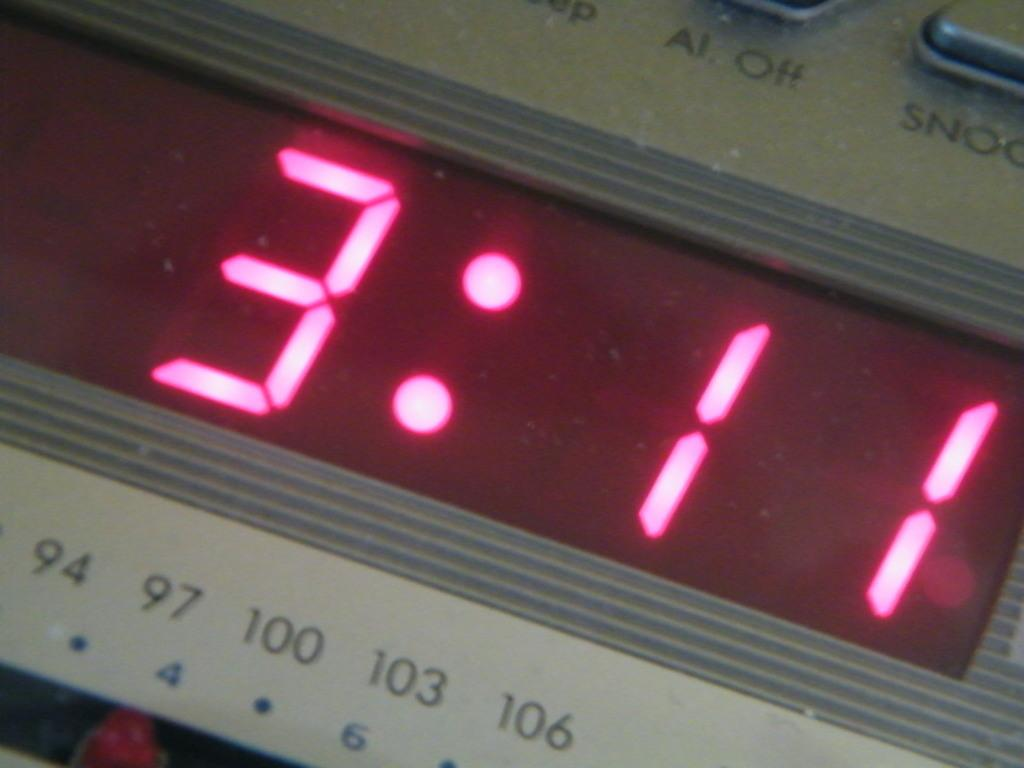<image>
Give a short and clear explanation of the subsequent image. The time 3:11 is displayed on a clock in red lettering. 